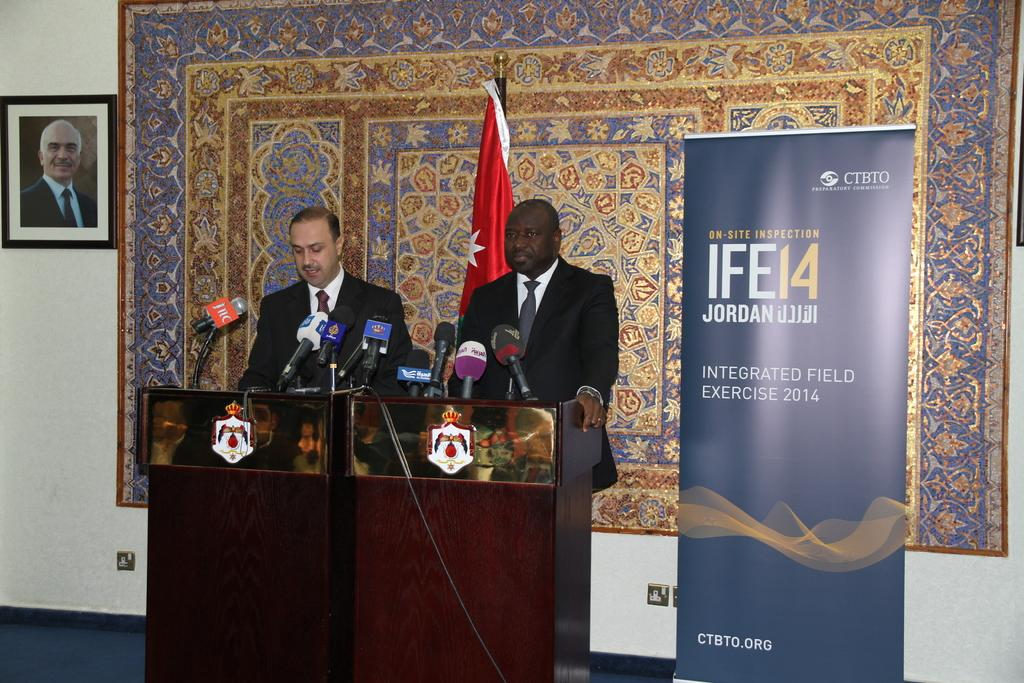<image>
Offer a succinct explanation of the picture presented. Two men stand at microphones next to a sign with the year 2014 on it. 